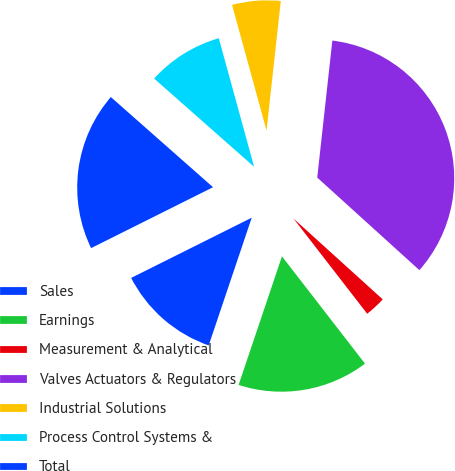<chart> <loc_0><loc_0><loc_500><loc_500><pie_chart><fcel>Sales<fcel>Earnings<fcel>Measurement & Analytical<fcel>Valves Actuators & Regulators<fcel>Industrial Solutions<fcel>Process Control Systems &<fcel>Total<nl><fcel>12.45%<fcel>15.66%<fcel>2.8%<fcel>34.97%<fcel>6.01%<fcel>9.23%<fcel>18.88%<nl></chart> 